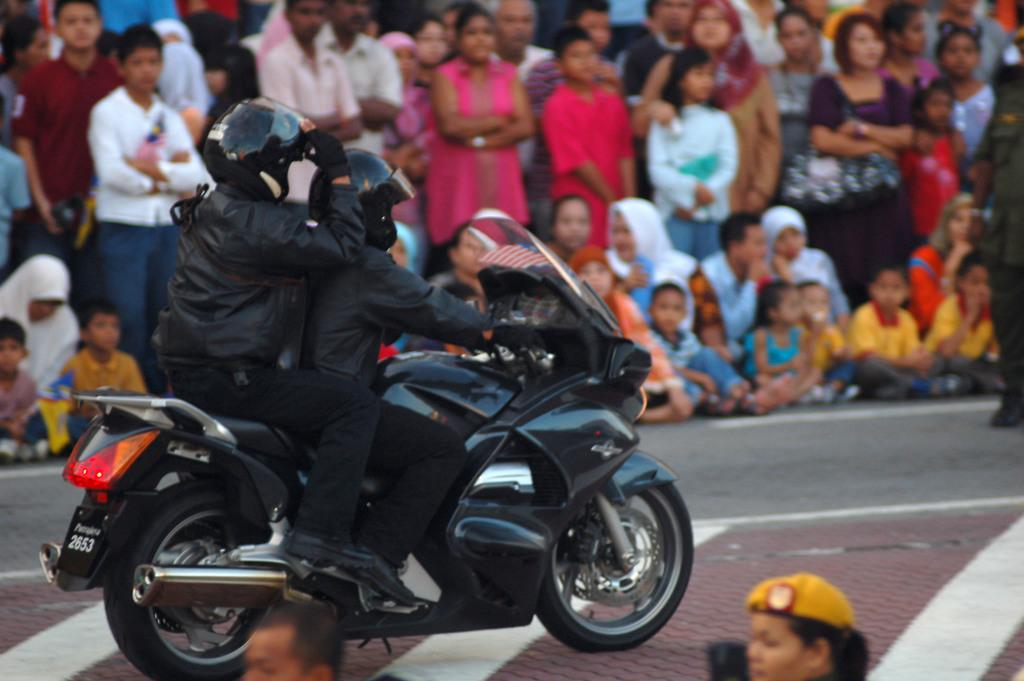How many people are in the image? There are two persons in the image. What are the people wearing? Both persons are wearing black dress. What are the people sitting on? The two persons are sitting on a black bike. Are there any other people visible in the image? Yes, there is an audience present beside them. What type of pen is the person holding in the image? There is no pen visible in the image; both persons are wearing black dress and sitting on a black bike. Can you see any crayons in the hands of the audience members? There is no mention of crayons or any other objects being held by the audience members in the image. 